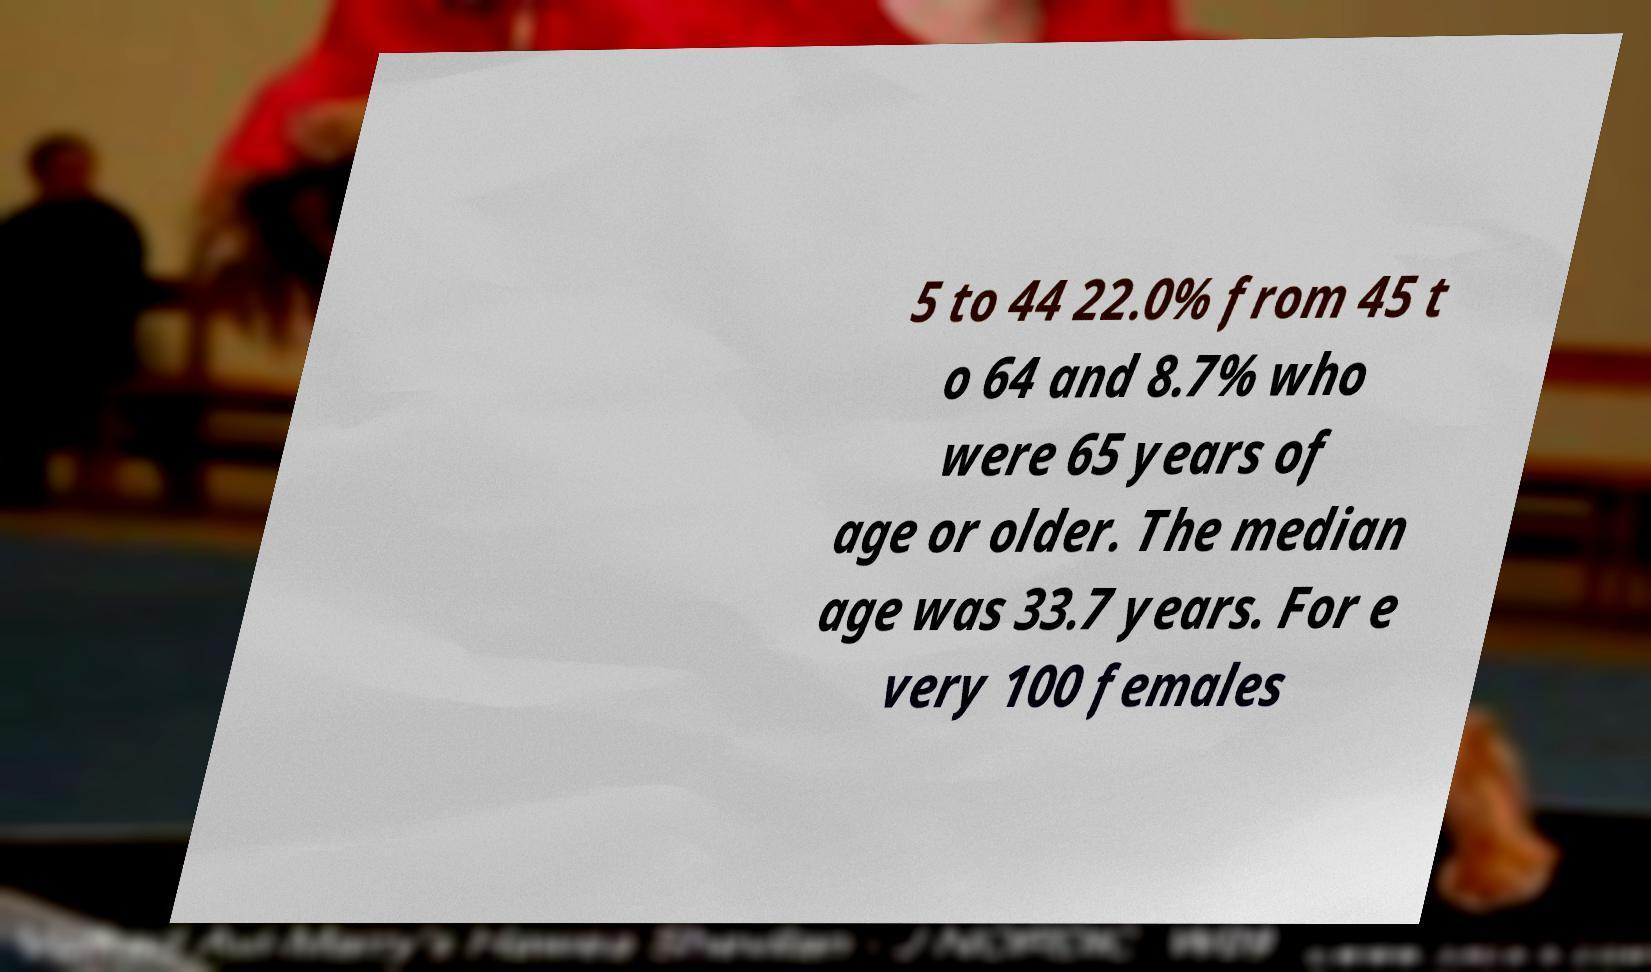What messages or text are displayed in this image? I need them in a readable, typed format. 5 to 44 22.0% from 45 t o 64 and 8.7% who were 65 years of age or older. The median age was 33.7 years. For e very 100 females 